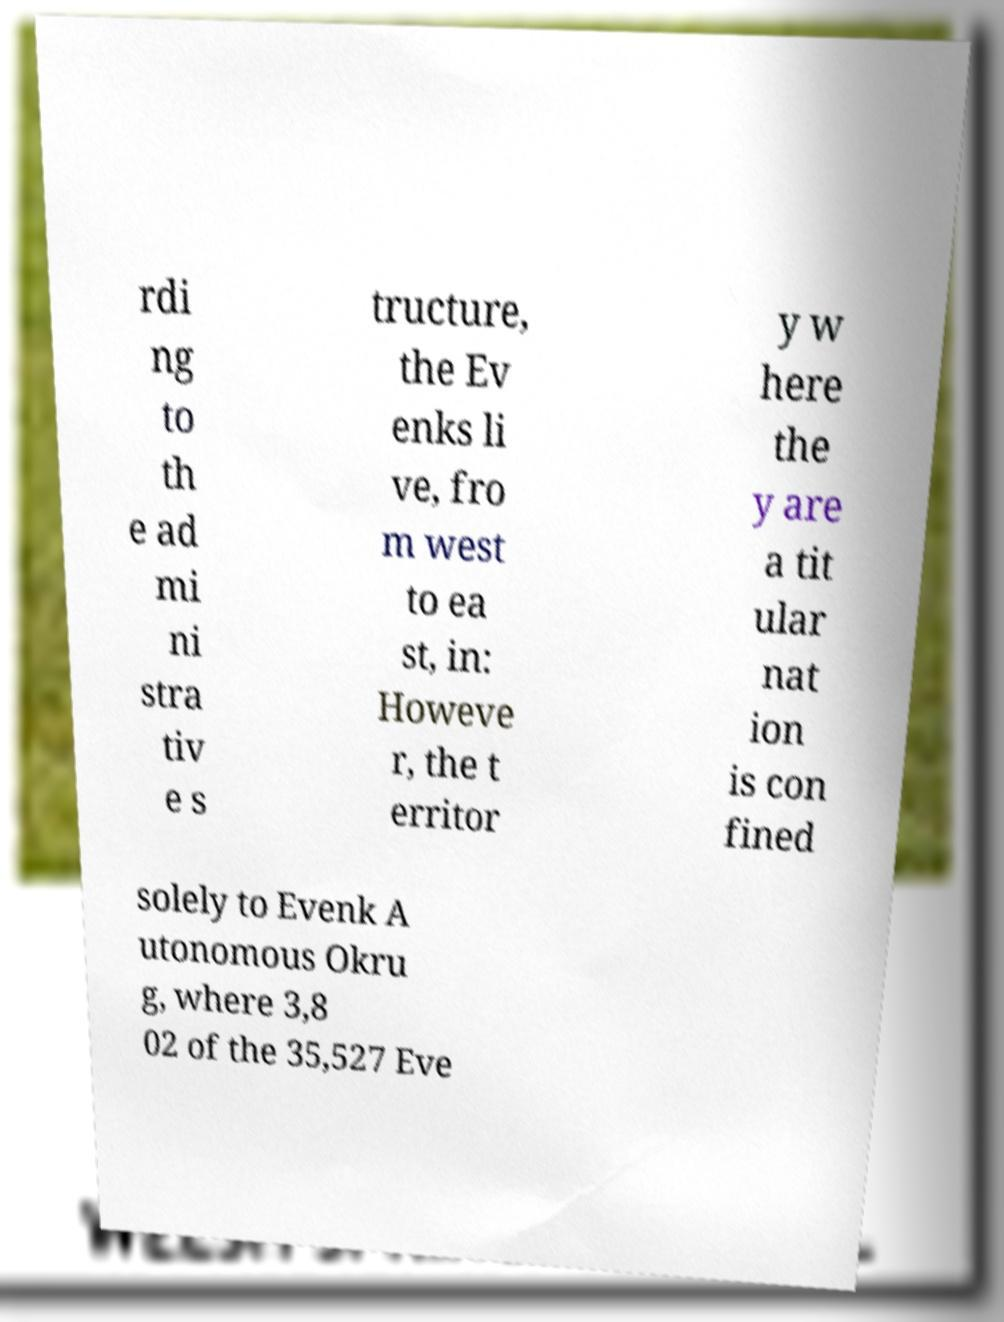Could you extract and type out the text from this image? rdi ng to th e ad mi ni stra tiv e s tructure, the Ev enks li ve, fro m west to ea st, in: Howeve r, the t erritor y w here the y are a tit ular nat ion is con fined solely to Evenk A utonomous Okru g, where 3,8 02 of the 35,527 Eve 